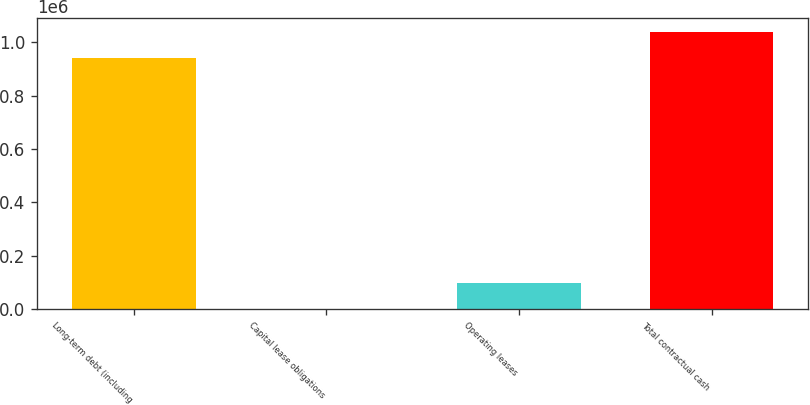Convert chart to OTSL. <chart><loc_0><loc_0><loc_500><loc_500><bar_chart><fcel>Long-term debt (including<fcel>Capital lease obligations<fcel>Operating leases<fcel>Total contractual cash<nl><fcel>941355<fcel>1230<fcel>98086.9<fcel>1.03821e+06<nl></chart> 